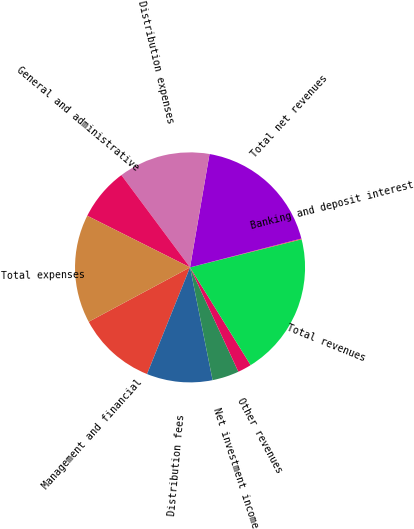Convert chart to OTSL. <chart><loc_0><loc_0><loc_500><loc_500><pie_chart><fcel>Management and financial<fcel>Distribution fees<fcel>Net investment income<fcel>Other revenues<fcel>Total revenues<fcel>Banking and deposit interest<fcel>Total net revenues<fcel>Distribution expenses<fcel>General and administrative<fcel>Total expenses<nl><fcel>11.06%<fcel>9.24%<fcel>3.76%<fcel>1.93%<fcel>20.09%<fcel>0.11%<fcel>18.26%<fcel>12.89%<fcel>7.41%<fcel>15.25%<nl></chart> 